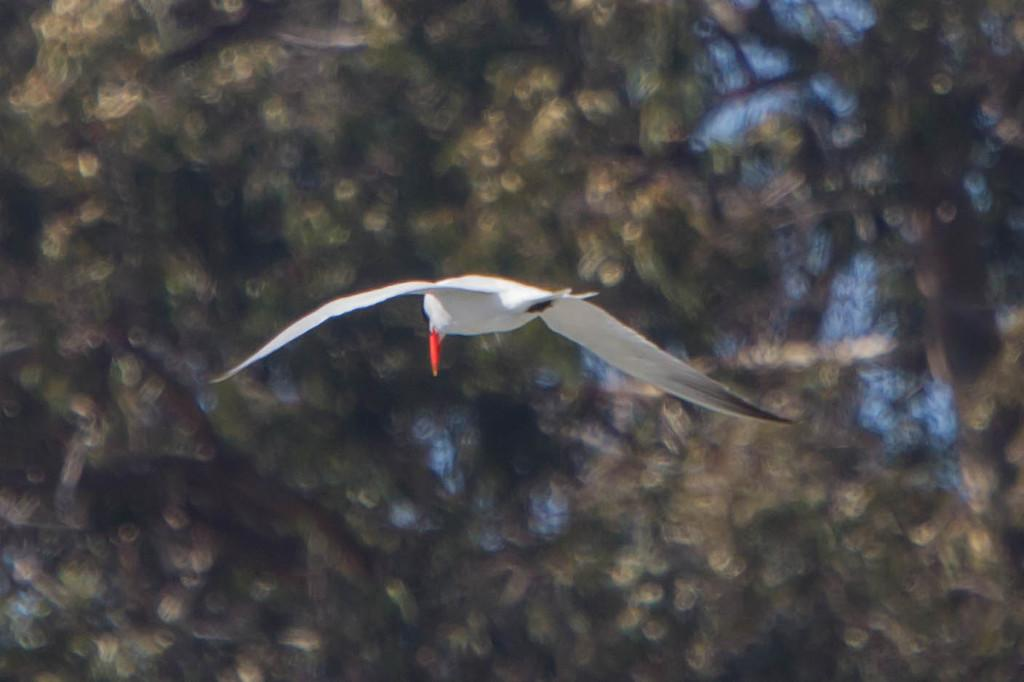What type of animal is in the image? There is a white color bird in the image. What is the bird doing in the image? The bird is flying. Can you describe the background of the image? The background of the image is blurry. What is the bird's net worth in the image? The bird's net worth cannot be determined from the image, as it does not provide information about the bird's financial status. 